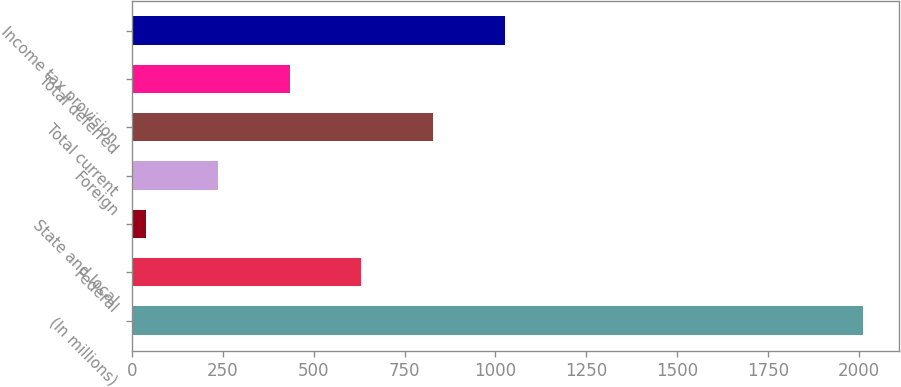<chart> <loc_0><loc_0><loc_500><loc_500><bar_chart><fcel>(In millions)<fcel>Federal<fcel>State and local<fcel>Foreign<fcel>Total current<fcel>Total deferred<fcel>Income tax provision<nl><fcel>2011<fcel>631.3<fcel>40<fcel>237.1<fcel>828.4<fcel>434.2<fcel>1025.5<nl></chart> 